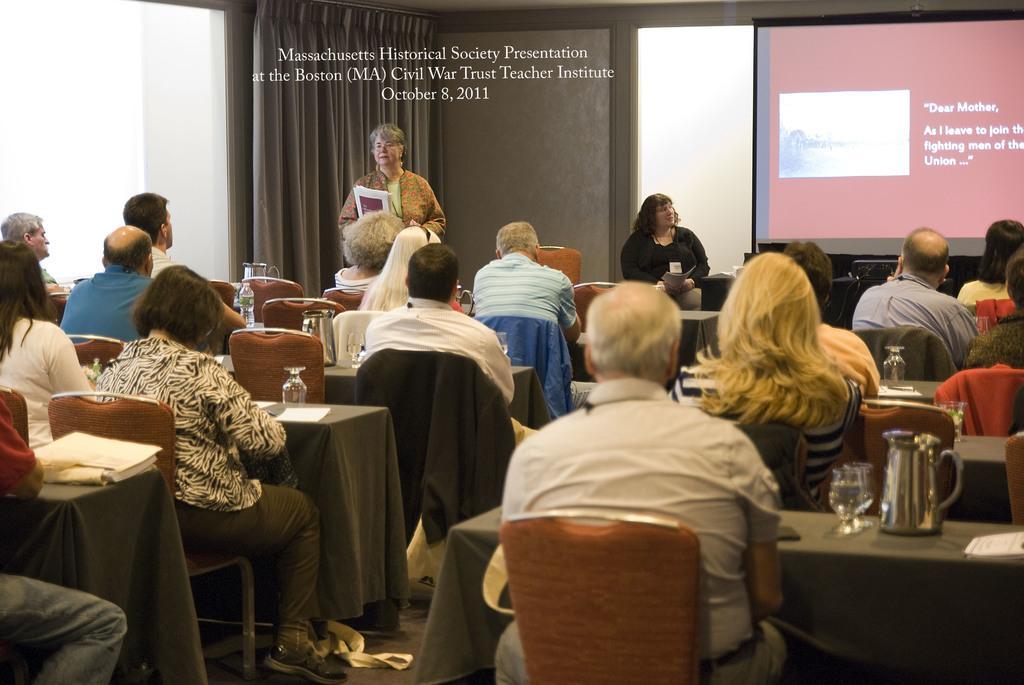How would you summarize this image in a sentence or two? In this image i can see few people sitting on chair at the bag ground i can see a woman standing, a woman sitting and a screen. 